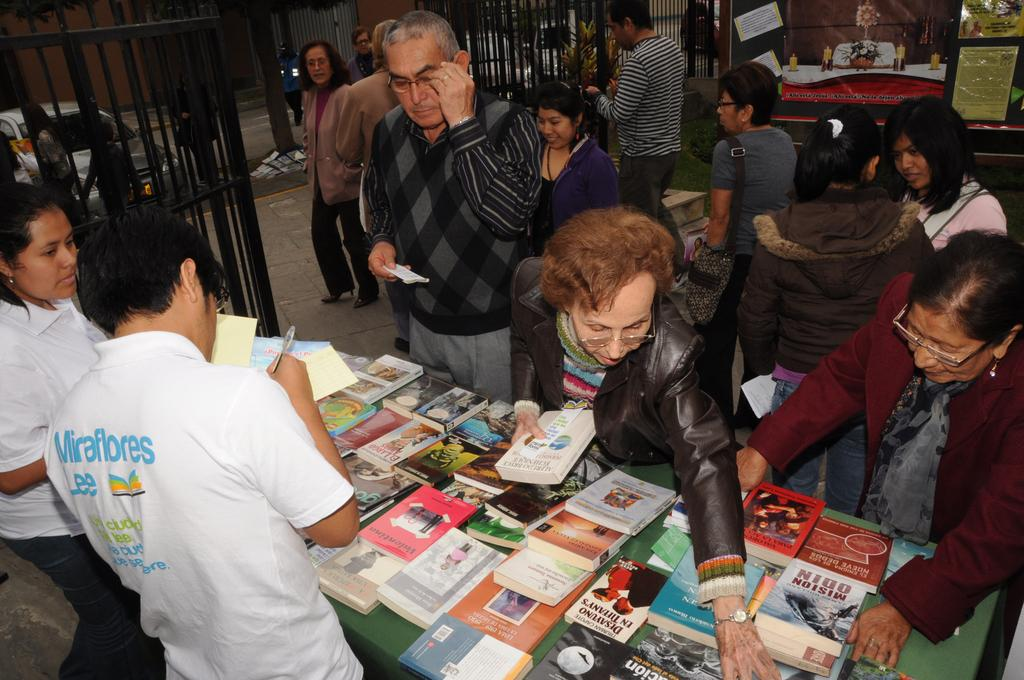<image>
Present a compact description of the photo's key features. A group of people are looking at books on the table including one called Mision Odin. 